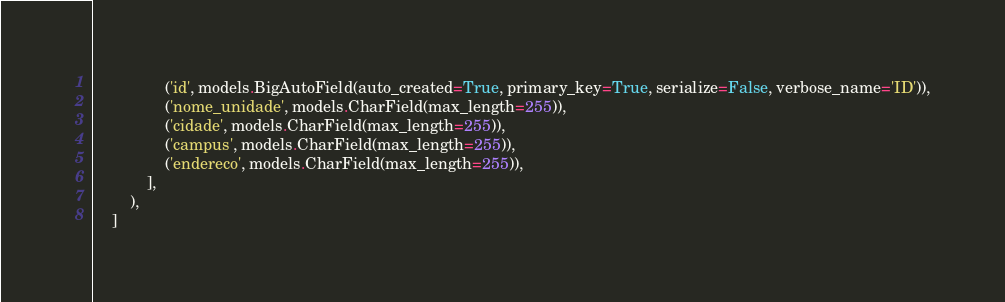<code> <loc_0><loc_0><loc_500><loc_500><_Python_>                ('id', models.BigAutoField(auto_created=True, primary_key=True, serialize=False, verbose_name='ID')),
                ('nome_unidade', models.CharField(max_length=255)),
                ('cidade', models.CharField(max_length=255)),
                ('campus', models.CharField(max_length=255)),
                ('endereco', models.CharField(max_length=255)),
            ],
        ),
    ]
</code> 